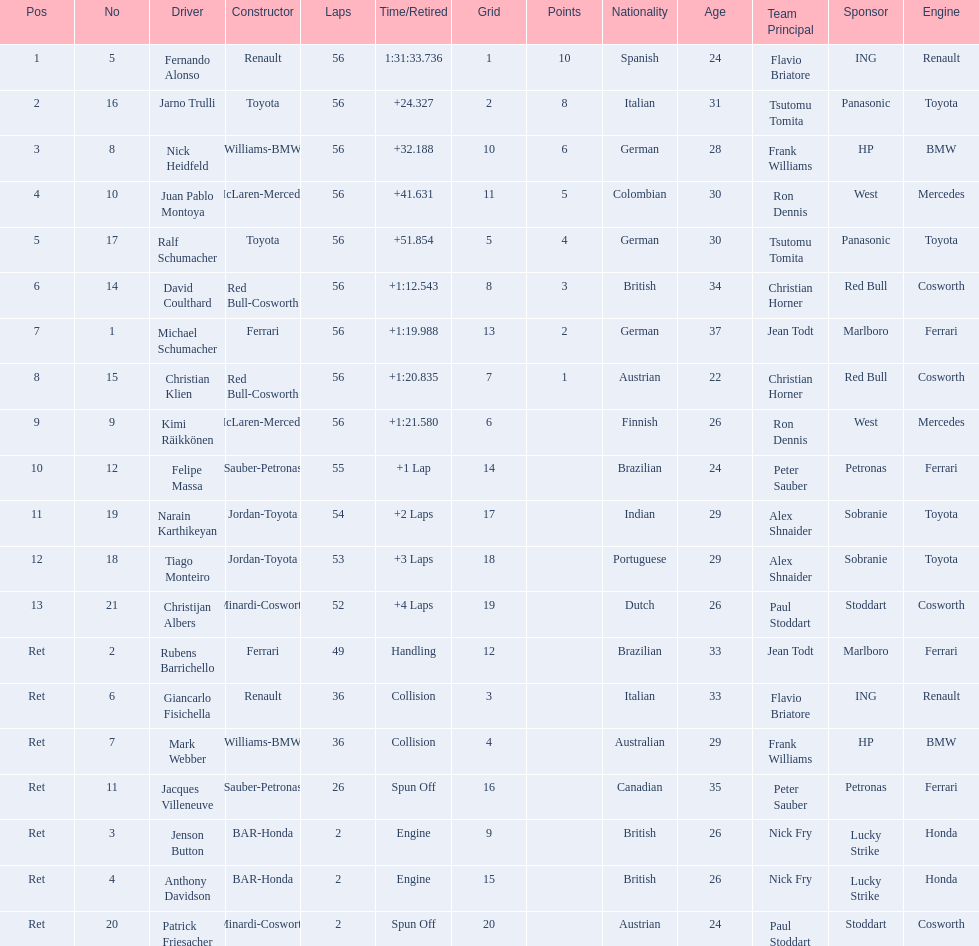Write the full table. {'header': ['Pos', 'No', 'Driver', 'Constructor', 'Laps', 'Time/Retired', 'Grid', 'Points', 'Nationality', 'Age', 'Team Principal', 'Sponsor', 'Engine'], 'rows': [['1', '5', 'Fernando Alonso', 'Renault', '56', '1:31:33.736', '1', '10', 'Spanish', '24', 'Flavio Briatore', 'ING', 'Renault'], ['2', '16', 'Jarno Trulli', 'Toyota', '56', '+24.327', '2', '8', 'Italian', '31', 'Tsutomu Tomita', 'Panasonic', 'Toyota'], ['3', '8', 'Nick Heidfeld', 'Williams-BMW', '56', '+32.188', '10', '6', 'German', '28', 'Frank Williams', 'HP', 'BMW'], ['4', '10', 'Juan Pablo Montoya', 'McLaren-Mercedes', '56', '+41.631', '11', '5', 'Colombian', '30', 'Ron Dennis', 'West', 'Mercedes'], ['5', '17', 'Ralf Schumacher', 'Toyota', '56', '+51.854', '5', '4', 'German', '30', 'Tsutomu Tomita', 'Panasonic', 'Toyota'], ['6', '14', 'David Coulthard', 'Red Bull-Cosworth', '56', '+1:12.543', '8', '3', 'British', '34', 'Christian Horner', 'Red Bull', 'Cosworth'], ['7', '1', 'Michael Schumacher', 'Ferrari', '56', '+1:19.988', '13', '2', 'German', '37', 'Jean Todt', 'Marlboro', 'Ferrari'], ['8', '15', 'Christian Klien', 'Red Bull-Cosworth', '56', '+1:20.835', '7', '1', 'Austrian', '22', 'Christian Horner', 'Red Bull', 'Cosworth'], ['9', '9', 'Kimi Räikkönen', 'McLaren-Mercedes', '56', '+1:21.580', '6', '', 'Finnish', '26', 'Ron Dennis', 'West', 'Mercedes'], ['10', '12', 'Felipe Massa', 'Sauber-Petronas', '55', '+1 Lap', '14', '', 'Brazilian', '24', 'Peter Sauber', 'Petronas', 'Ferrari'], ['11', '19', 'Narain Karthikeyan', 'Jordan-Toyota', '54', '+2 Laps', '17', '', 'Indian', '29', 'Alex Shnaider', 'Sobranie', 'Toyota'], ['12', '18', 'Tiago Monteiro', 'Jordan-Toyota', '53', '+3 Laps', '18', '', 'Portuguese', '29', 'Alex Shnaider', 'Sobranie', 'Toyota'], ['13', '21', 'Christijan Albers', 'Minardi-Cosworth', '52', '+4 Laps', '19', '', 'Dutch', '26', 'Paul Stoddart', 'Stoddart', 'Cosworth'], ['Ret', '2', 'Rubens Barrichello', 'Ferrari', '49', 'Handling', '12', '', 'Brazilian', '33', 'Jean Todt', 'Marlboro', 'Ferrari'], ['Ret', '6', 'Giancarlo Fisichella', 'Renault', '36', 'Collision', '3', '', 'Italian', '33', 'Flavio Briatore', 'ING', 'Renault'], ['Ret', '7', 'Mark Webber', 'Williams-BMW', '36', 'Collision', '4', '', 'Australian', '29', 'Frank Williams', 'HP', 'BMW'], ['Ret', '11', 'Jacques Villeneuve', 'Sauber-Petronas', '26', 'Spun Off', '16', '', 'Canadian', '35', 'Peter Sauber', 'Petronas', 'Ferrari'], ['Ret', '3', 'Jenson Button', 'BAR-Honda', '2', 'Engine', '9', '', 'British', '26', 'Nick Fry', 'Lucky Strike', 'Honda'], ['Ret', '4', 'Anthony Davidson', 'BAR-Honda', '2', 'Engine', '15', '', 'British', '26', 'Nick Fry', 'Lucky Strike', 'Honda'], ['Ret', '20', 'Patrick Friesacher', 'Minardi-Cosworth', '2', 'Spun Off', '20', '', 'Austrian', '24', 'Paul Stoddart', 'Stoddart', 'Cosworth']]} How many drivers were retired before the race could end? 7. 